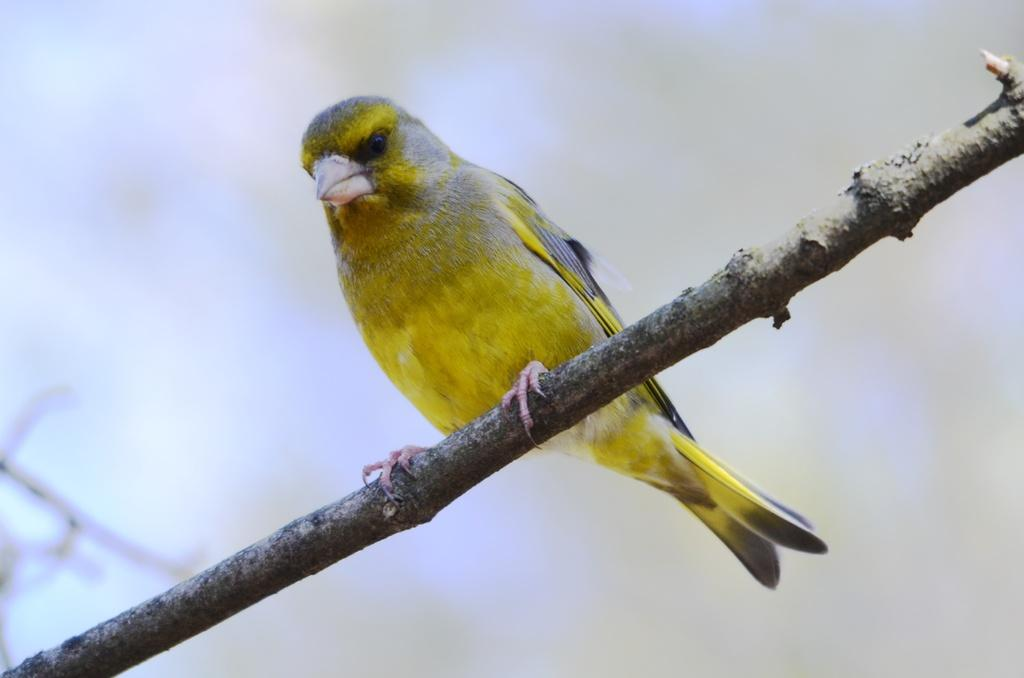What object can be seen in the image? There is a wooden stick in the image. What is on the wooden stick? There is a yellow-colored bird on the wooden stick. How would you describe the overall clarity of the image? The image is slightly blurry in the background. Can you tell me the story behind the fog in the image? There is no fog present in the image, so there is no story to tell about it. 